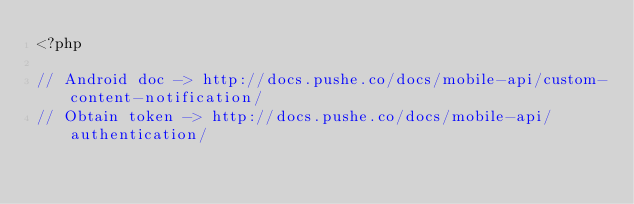Convert code to text. <code><loc_0><loc_0><loc_500><loc_500><_PHP_><?php

// Android doc -> http://docs.pushe.co/docs/mobile-api/custom-content-notification/
// Obtain token -> http://docs.pushe.co/docs/mobile-api/authentication/</code> 